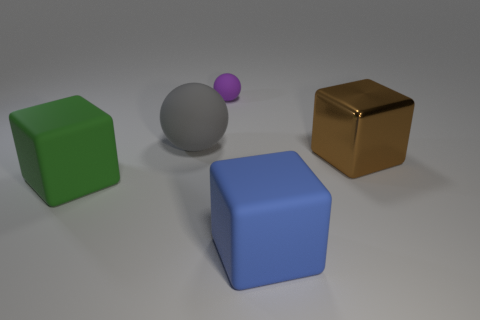Which object stands out the most due to its color? The object that stands out the most due to its color is the green cube, as it offers the highest contrast against the more subdued colors of the other shapes in the scene. 